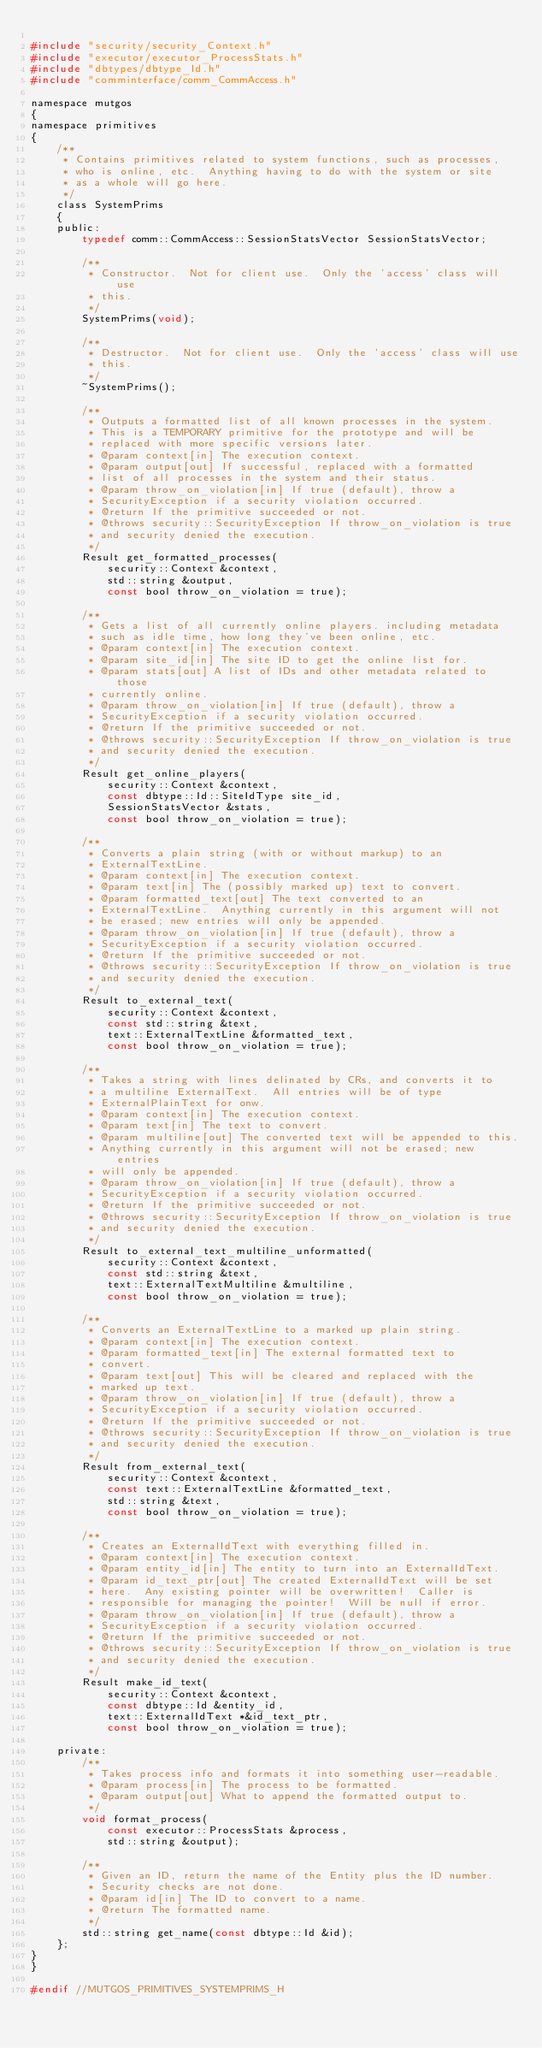<code> <loc_0><loc_0><loc_500><loc_500><_C_>
#include "security/security_Context.h"
#include "executor/executor_ProcessStats.h"
#include "dbtypes/dbtype_Id.h"
#include "comminterface/comm_CommAccess.h"

namespace mutgos
{
namespace primitives
{
    /**
     * Contains primitives related to system functions, such as processes,
     * who is online, etc.  Anything having to do with the system or site
     * as a whole will go here.
     */
    class SystemPrims
    {
    public:
        typedef comm::CommAccess::SessionStatsVector SessionStatsVector;

        /**
         * Constructor.  Not for client use.  Only the 'access' class will use
         * this.
         */
        SystemPrims(void);

        /**
         * Destructor.  Not for client use.  Only the 'access' class will use
         * this.
         */
        ~SystemPrims();

        /**
         * Outputs a formatted list of all known processes in the system.
         * This is a TEMPORARY primitive for the prototype and will be
         * replaced with more specific versions later.
         * @param context[in] The execution context.
         * @param output[out] If successful, replaced with a formatted
         * list of all processes in the system and their status.
         * @param throw_on_violation[in] If true (default), throw a
         * SecurityException if a security violation occurred.
         * @return If the primitive succeeded or not.
         * @throws security::SecurityException If throw_on_violation is true
         * and security denied the execution.
         */
        Result get_formatted_processes(
            security::Context &context,
            std::string &output,
            const bool throw_on_violation = true);

        /**
         * Gets a list of all currently online players. including metadata
         * such as idle time, how long they've been online, etc.
         * @param context[in] The execution context.
         * @param site_id[in] The site ID to get the online list for.
         * @param stats[out] A list of IDs and other metadata related to those
         * currently online.
         * @param throw_on_violation[in] If true (default), throw a
         * SecurityException if a security violation occurred.
         * @return If the primitive succeeded or not.
         * @throws security::SecurityException If throw_on_violation is true
         * and security denied the execution.
         */
        Result get_online_players(
            security::Context &context,
            const dbtype::Id::SiteIdType site_id,
            SessionStatsVector &stats,
            const bool throw_on_violation = true);

        /**
         * Converts a plain string (with or without markup) to an
         * ExternalTextLine.
         * @param context[in] The execution context.
         * @param text[in] The (possibly marked up) text to convert.
         * @param formatted_text[out] The text converted to an
         * ExternalTextLine.  Anything currently in this argument will not
         * be erased; new entries will only be appended.
         * @param throw_on_violation[in] If true (default), throw a
         * SecurityException if a security violation occurred.
         * @return If the primitive succeeded or not.
         * @throws security::SecurityException If throw_on_violation is true
         * and security denied the execution.
         */
        Result to_external_text(
            security::Context &context,
            const std::string &text,
            text::ExternalTextLine &formatted_text,
            const bool throw_on_violation = true);

        /**
         * Takes a string with lines delinated by CRs, and converts it to
         * a multiline ExternalText.  All entries will be of type
         * ExternalPlainText for onw.
         * @param context[in] The execution context.
         * @param text[in] The text to convert.
         * @param multiline[out] The converted text will be appended to this.
         * Anything currently in this argument will not be erased; new entries
         * will only be appended.
         * @param throw_on_violation[in] If true (default), throw a
         * SecurityException if a security violation occurred.
         * @return If the primitive succeeded or not.
         * @throws security::SecurityException If throw_on_violation is true
         * and security denied the execution.
         */
        Result to_external_text_multiline_unformatted(
            security::Context &context,
            const std::string &text,
            text::ExternalTextMultiline &multiline,
            const bool throw_on_violation = true);

        /**
         * Converts an ExternalTextLine to a marked up plain string.
         * @param context[in] The execution context.
         * @param formatted_text[in] The external formatted text to
         * convert.
         * @param text[out] This will be cleared and replaced with the
         * marked up text.
         * @param throw_on_violation[in] If true (default), throw a
         * SecurityException if a security violation occurred.
         * @return If the primitive succeeded or not.
         * @throws security::SecurityException If throw_on_violation is true
         * and security denied the execution.
         */
        Result from_external_text(
            security::Context &context,
            const text::ExternalTextLine &formatted_text,
            std::string &text,
            const bool throw_on_violation = true);

        /**
         * Creates an ExternalIdText with everything filled in.
         * @param context[in] The execution context.
         * @param entity_id[in] The entity to turn into an ExternalIdText.
         * @param id_text_ptr[out] The created ExternalIdText will be set
         * here.  Any existing pointer will be overwritten!  Caller is
         * responsible for managing the pointer!  Will be null if error.
         * @param throw_on_violation[in] If true (default), throw a
         * SecurityException if a security violation occurred.
         * @return If the primitive succeeded or not.
         * @throws security::SecurityException If throw_on_violation is true
         * and security denied the execution.
         */
        Result make_id_text(
            security::Context &context,
            const dbtype::Id &entity_id,
            text::ExternalIdText *&id_text_ptr,
            const bool throw_on_violation = true);

    private:
        /**
         * Takes process info and formats it into something user-readable.
         * @param process[in] The process to be formatted.
         * @param output[out] What to append the formatted output to.
         */
        void format_process(
            const executor::ProcessStats &process,
            std::string &output);

        /**
         * Given an ID, return the name of the Entity plus the ID number.
         * Security checks are not done.
         * @param id[in] The ID to convert to a name.
         * @return The formatted name.
         */
        std::string get_name(const dbtype::Id &id);
    };
}
}

#endif //MUTGOS_PRIMITIVES_SYSTEMPRIMS_H
</code> 